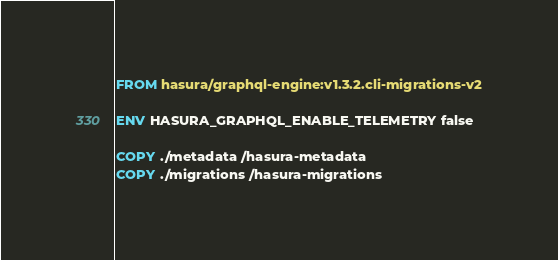<code> <loc_0><loc_0><loc_500><loc_500><_Dockerfile_>FROM hasura/graphql-engine:v1.3.2.cli-migrations-v2

ENV HASURA_GRAPHQL_ENABLE_TELEMETRY false

COPY ./metadata /hasura-metadata
COPY ./migrations /hasura-migrations
</code> 